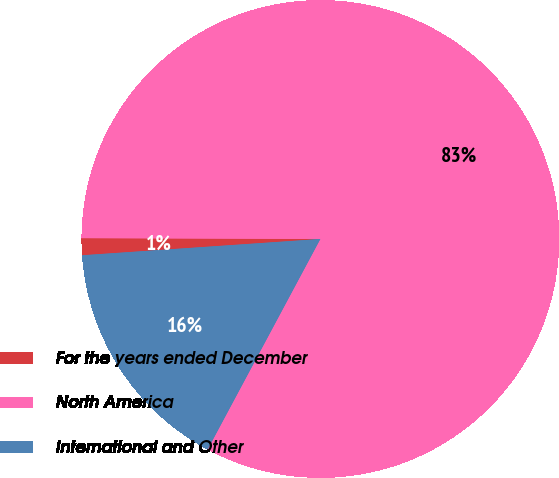<chart> <loc_0><loc_0><loc_500><loc_500><pie_chart><fcel>For the years ended December<fcel>North America<fcel>International and Other<nl><fcel>1.14%<fcel>82.78%<fcel>16.09%<nl></chart> 